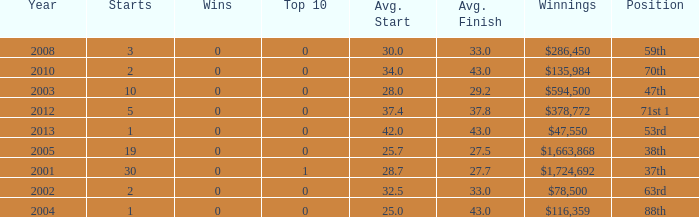How many starts for an average finish greater than 43? None. Can you give me this table as a dict? {'header': ['Year', 'Starts', 'Wins', 'Top 10', 'Avg. Start', 'Avg. Finish', 'Winnings', 'Position'], 'rows': [['2008', '3', '0', '0', '30.0', '33.0', '$286,450', '59th'], ['2010', '2', '0', '0', '34.0', '43.0', '$135,984', '70th'], ['2003', '10', '0', '0', '28.0', '29.2', '$594,500', '47th'], ['2012', '5', '0', '0', '37.4', '37.8', '$378,772', '71st 1'], ['2013', '1', '0', '0', '42.0', '43.0', '$47,550', '53rd'], ['2005', '19', '0', '0', '25.7', '27.5', '$1,663,868', '38th'], ['2001', '30', '0', '1', '28.7', '27.7', '$1,724,692', '37th'], ['2002', '2', '0', '0', '32.5', '33.0', '$78,500', '63rd'], ['2004', '1', '0', '0', '25.0', '43.0', '$116,359', '88th']]} 